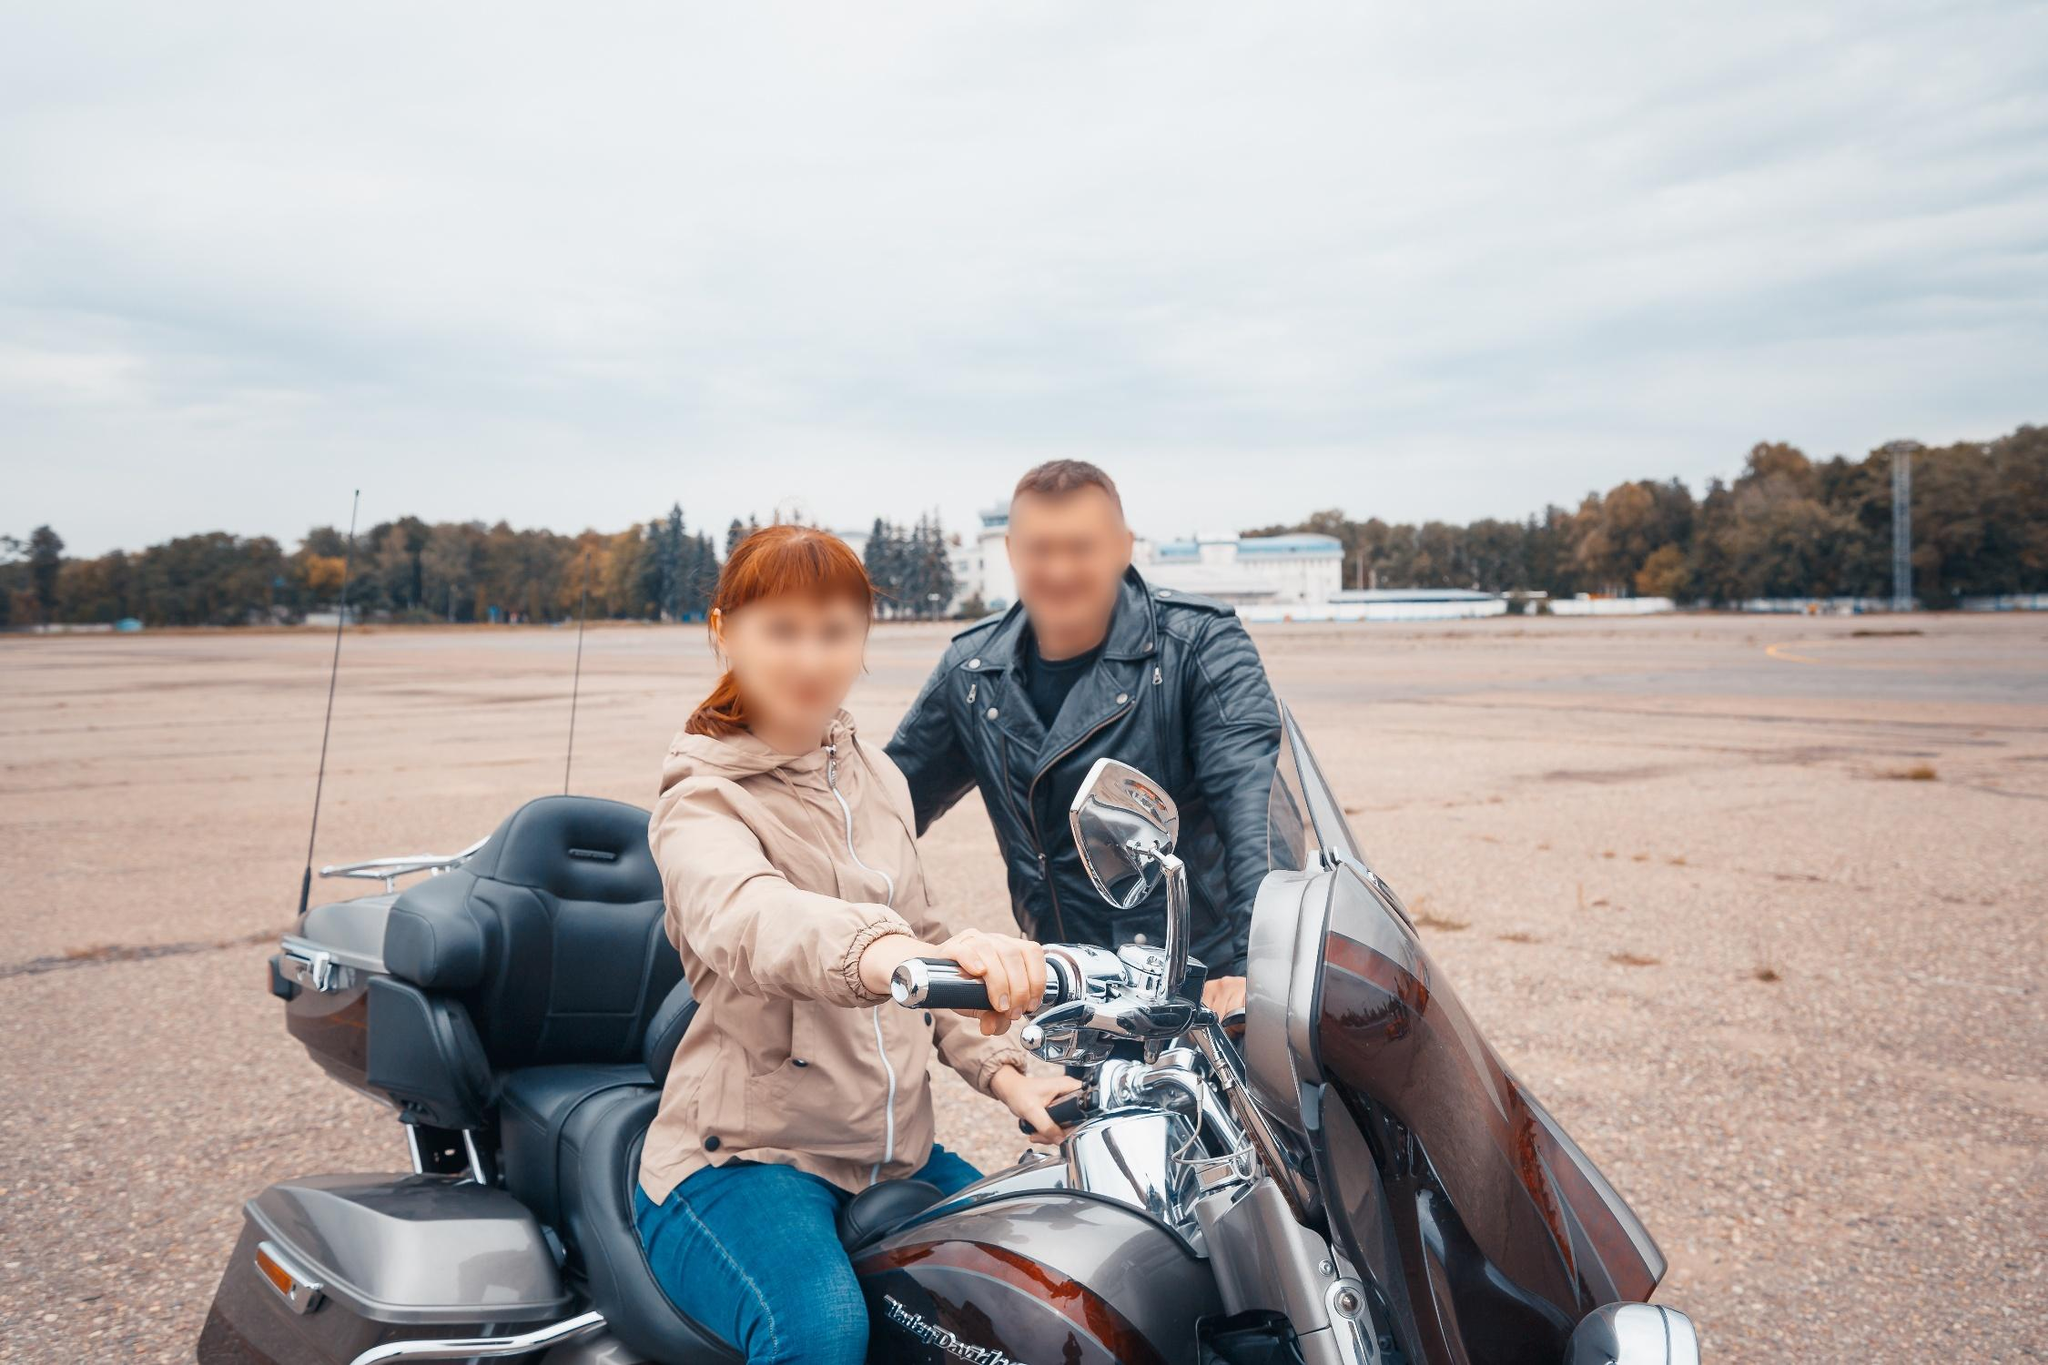Can you elaborate on the elements of the picture provided? The image portrays a serene and picturesque scene where a man and a woman are seen sitting on a gleaming black Harley Davidson motorcycle. They are positioned on a vast, open gravel area that appears to be a large lot or parking space. The woman's attire consists of a beige jacket and blue jeans, and she is seated at the front of the motorcycle, holding the handlebars. Behind her, the man is dressed in a black leather jacket and blue jeans, leaning slightly as if preparing to join the ride or provide support. Both individuals have blurred faces, maintaining their privacy. The motorcycle is prominently displayed with a shiny silver engine and handlebars contrasting against the muted, overcast sky and the tranquil background of distant trees. The image captures the essence of a calm, almost contemplative moment, with no additional objects or text, focusing solely on the interaction between the riders and the impressive vehicle. 